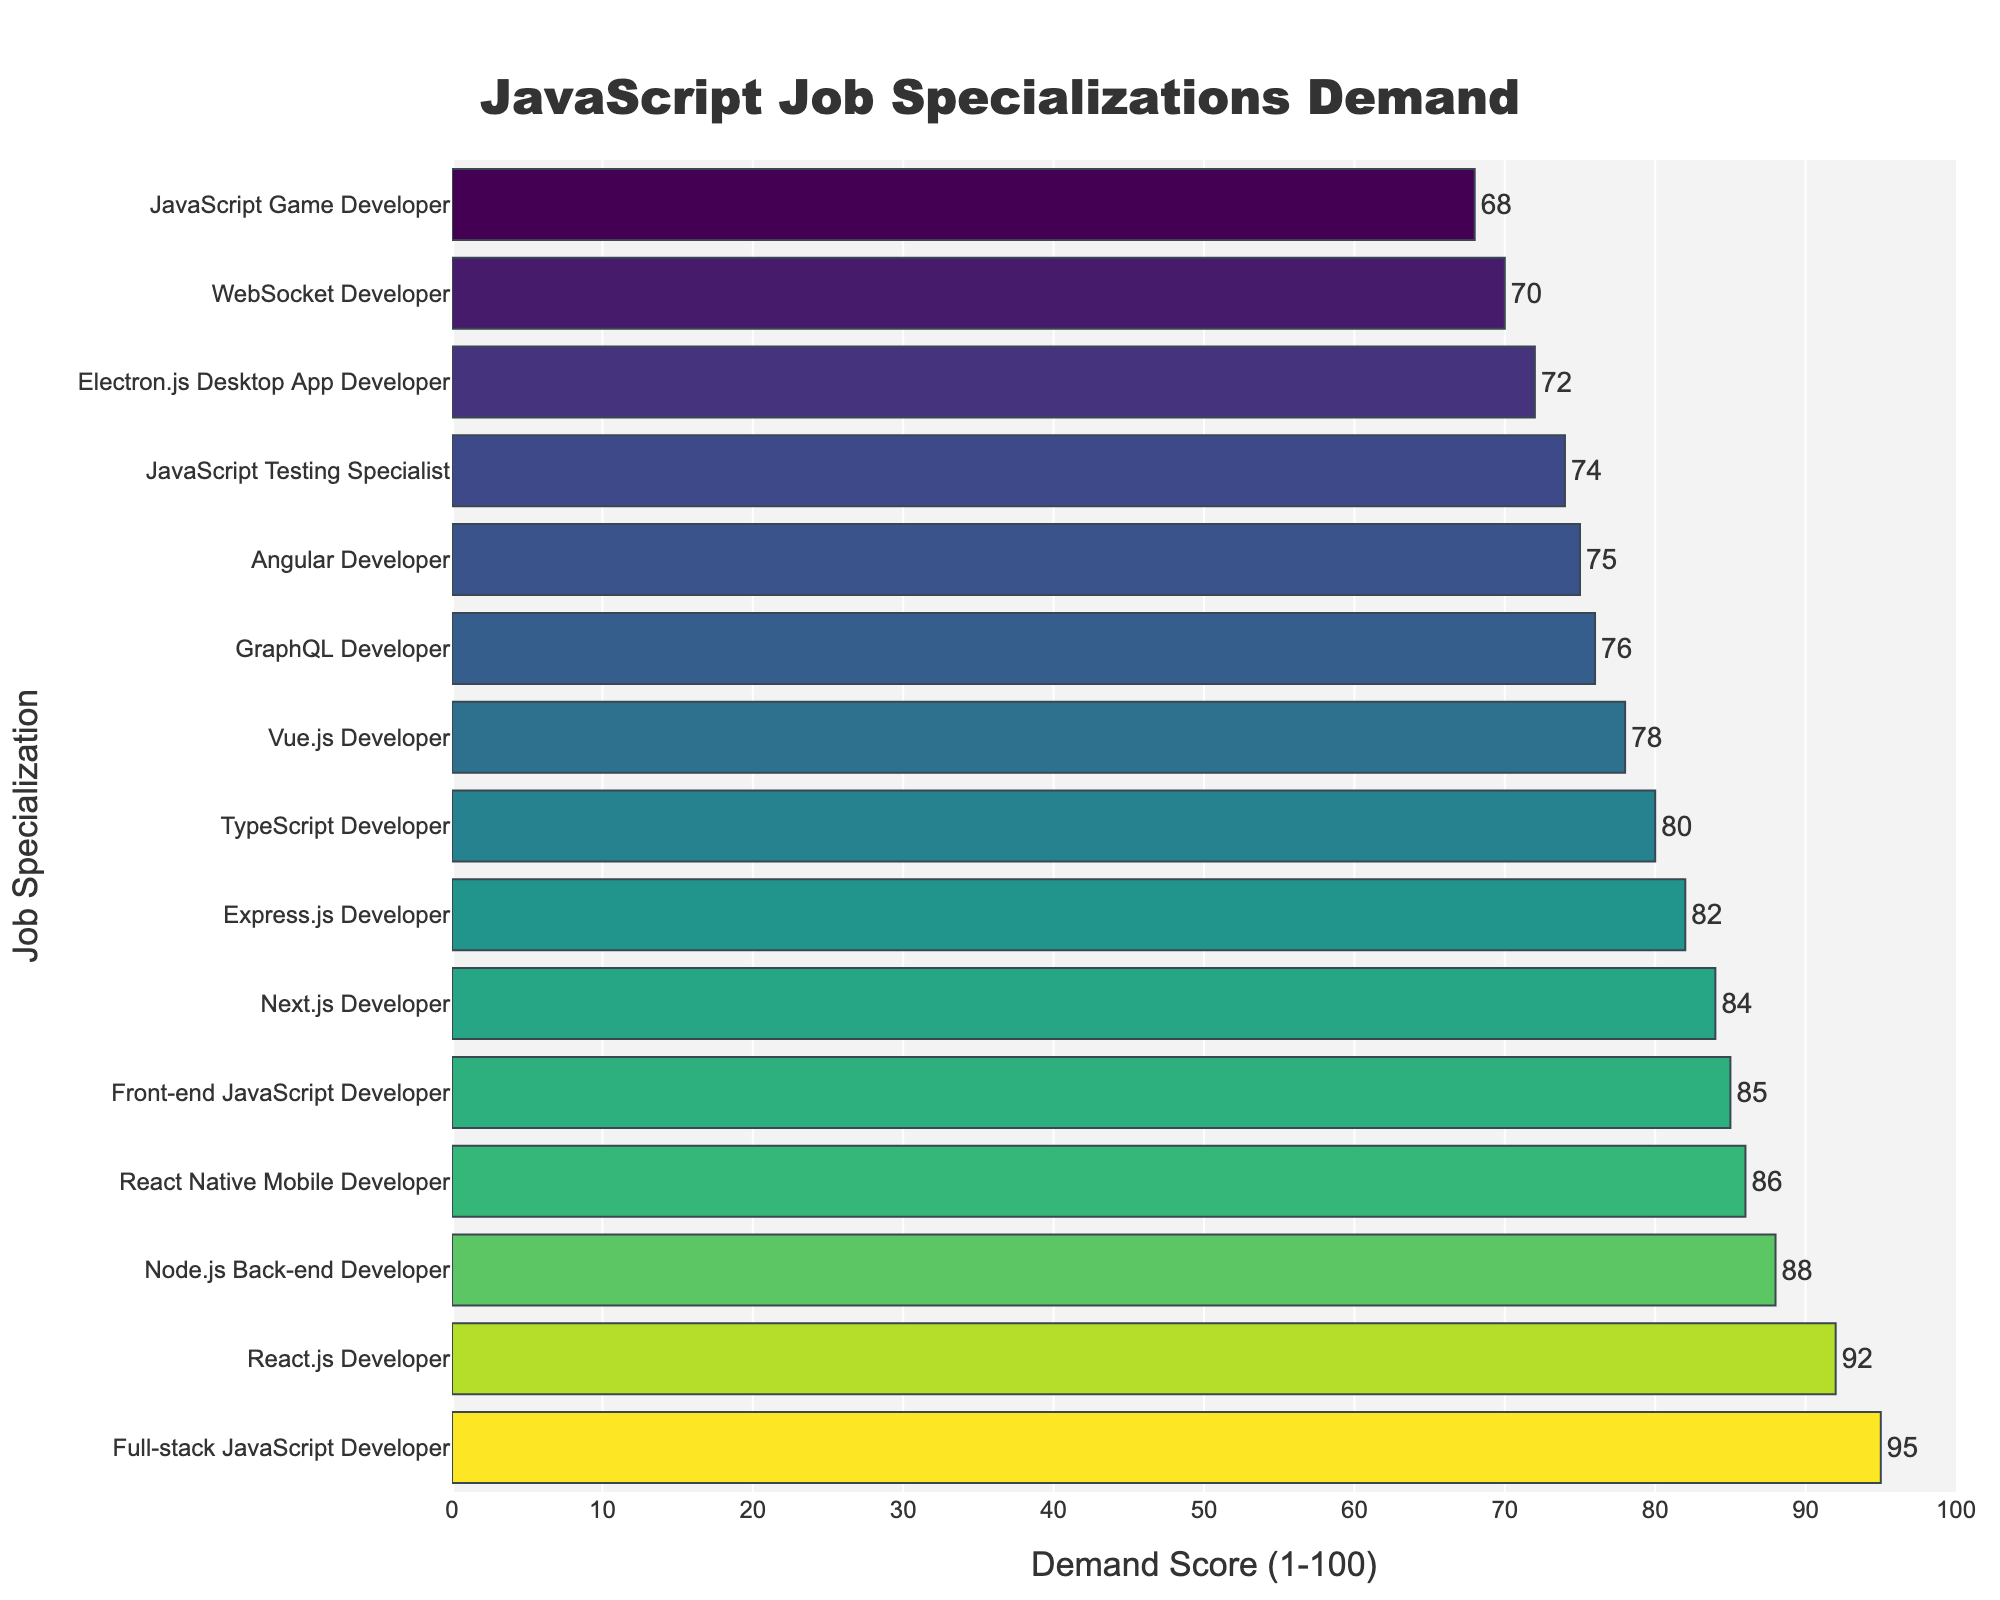Which JavaScript job specialization has the highest demand score? The figure lists the demand scores for various JavaScript specializations. By inspecting the bar heights, the Full-stack JavaScript Developer has the highest score, which is 95.
Answer: Full-stack JavaScript Developer Which specialization has a higher demand score: React.js Developer or Angular Developer? In the figure, the bar for React.js Developer is higher than the bar for Angular Developer. The demand score for React.js Developer is 92, while for Angular Developer it is 75, indicating that React.js Developer has a higher demand score.
Answer: React.js Developer What is the median demand score for all JavaScript specializations? To find the median, sort all the demand scores in ascending order and find the middle value. The scores are: 68, 70, 72, 74, 75, 76, 78, 80, 82, 84, 85, 86, 88, 92, 95. There are 15 data points, so the median is the 8th value, which is 80.
Answer: 80 How much higher is the demand score for Node.js Back-end Developer compared to Vue.js Developer? The demand score for Node.js Back-end Developer is 88 and for Vue.js Developer is 78. The difference is 88 - 78 = 10. Thus, Node.js Back-end Developer has a demand score that is 10 points higher than Vue.js Developer.
Answer: 10 Which specialization has the lowest demand score, and what is that score? The bar corresponding to JavaScript Game Developer is the shortest in the figure, which represents the lowest demand score. The demand score for JavaScript Game Developer is 68.
Answer: JavaScript Game Developer Which specialization's bar color indicates it has a demand score in the 80s? Inspect the colors corresponding to demand scores in the 80s. TypeScript Developer, Express.js Developer, and Next.js Developer all have bars that fall within this range, indicating demand scores in the 80s.
Answer: TypeScript Developer, Express.js Developer, Next.js Developer What is the average demand score for Full-stack JavaScript Developer, React.js Developer, and Node.js Back-end Developer? The demand scores are Full-stack JavaScript Developer (95), React.js Developer (92), and Node.js Back-end Developer (88). Average = (95 + 92 + 88) / 3 = 91.67.
Answer: 91.67 What is the total demand score for all mobile and desktop-related specializations combined? The relevant specializations and their scores are Electron.js Desktop App Developer (72) and React Native Mobile Developer (86). Total demand score = 72 + 86 = 158.
Answer: 158 How many JavaScript specializations have demand scores greater than 80? The specializations with demand scores over 80 are: Full-stack JavaScript Developer (95), React.js Developer (92), Node.js Back-end Developer (88), React Native Mobile Developer (86), Front-end JavaScript Developer (85), Next.js Developer (84), Express.js Developer (82). There are 7 of such specializations.
Answer: 7 Which specialization has a color different from the others when observing the figure's color gradient? By observing the color gradient, Full-stack JavaScript Developer stands out as it has the highest demand score and therefore a unique color that corresponds to the highest end of the gradient scale.
Answer: Full-stack JavaScript Developer 